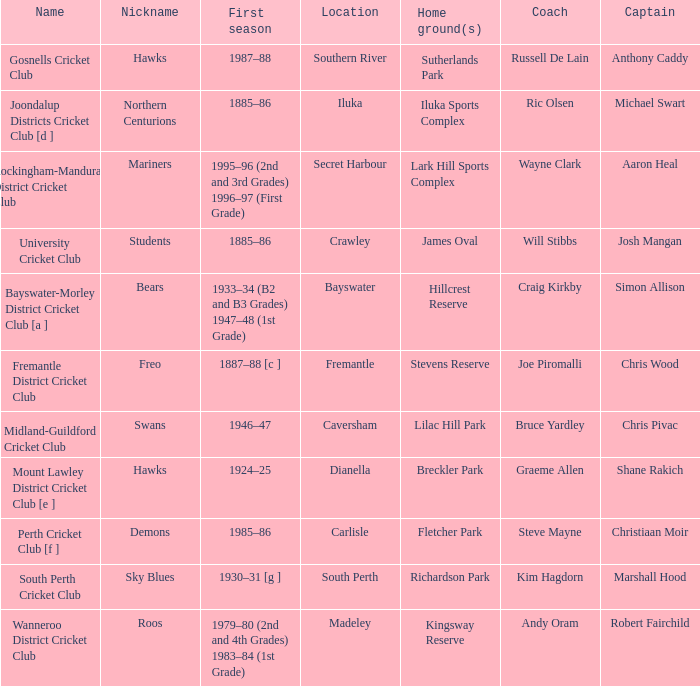What is the code nickname where Steve Mayne is the coach? Demons. Can you give me this table as a dict? {'header': ['Name', 'Nickname', 'First season', 'Location', 'Home ground(s)', 'Coach', 'Captain'], 'rows': [['Gosnells Cricket Club', 'Hawks', '1987–88', 'Southern River', 'Sutherlands Park', 'Russell De Lain', 'Anthony Caddy'], ['Joondalup Districts Cricket Club [d ]', 'Northern Centurions', '1885–86', 'Iluka', 'Iluka Sports Complex', 'Ric Olsen', 'Michael Swart'], ['Rockingham-Mandurah District Cricket Club', 'Mariners', '1995–96 (2nd and 3rd Grades) 1996–97 (First Grade)', 'Secret Harbour', 'Lark Hill Sports Complex', 'Wayne Clark', 'Aaron Heal'], ['University Cricket Club', 'Students', '1885–86', 'Crawley', 'James Oval', 'Will Stibbs', 'Josh Mangan'], ['Bayswater-Morley District Cricket Club [a ]', 'Bears', '1933–34 (B2 and B3 Grades) 1947–48 (1st Grade)', 'Bayswater', 'Hillcrest Reserve', 'Craig Kirkby', 'Simon Allison'], ['Fremantle District Cricket Club', 'Freo', '1887–88 [c ]', 'Fremantle', 'Stevens Reserve', 'Joe Piromalli', 'Chris Wood'], ['Midland-Guildford Cricket Club', 'Swans', '1946–47', 'Caversham', 'Lilac Hill Park', 'Bruce Yardley', 'Chris Pivac'], ['Mount Lawley District Cricket Club [e ]', 'Hawks', '1924–25', 'Dianella', 'Breckler Park', 'Graeme Allen', 'Shane Rakich'], ['Perth Cricket Club [f ]', 'Demons', '1985–86', 'Carlisle', 'Fletcher Park', 'Steve Mayne', 'Christiaan Moir'], ['South Perth Cricket Club', 'Sky Blues', '1930–31 [g ]', 'South Perth', 'Richardson Park', 'Kim Hagdorn', 'Marshall Hood'], ['Wanneroo District Cricket Club', 'Roos', '1979–80 (2nd and 4th Grades) 1983–84 (1st Grade)', 'Madeley', 'Kingsway Reserve', 'Andy Oram', 'Robert Fairchild']]} 